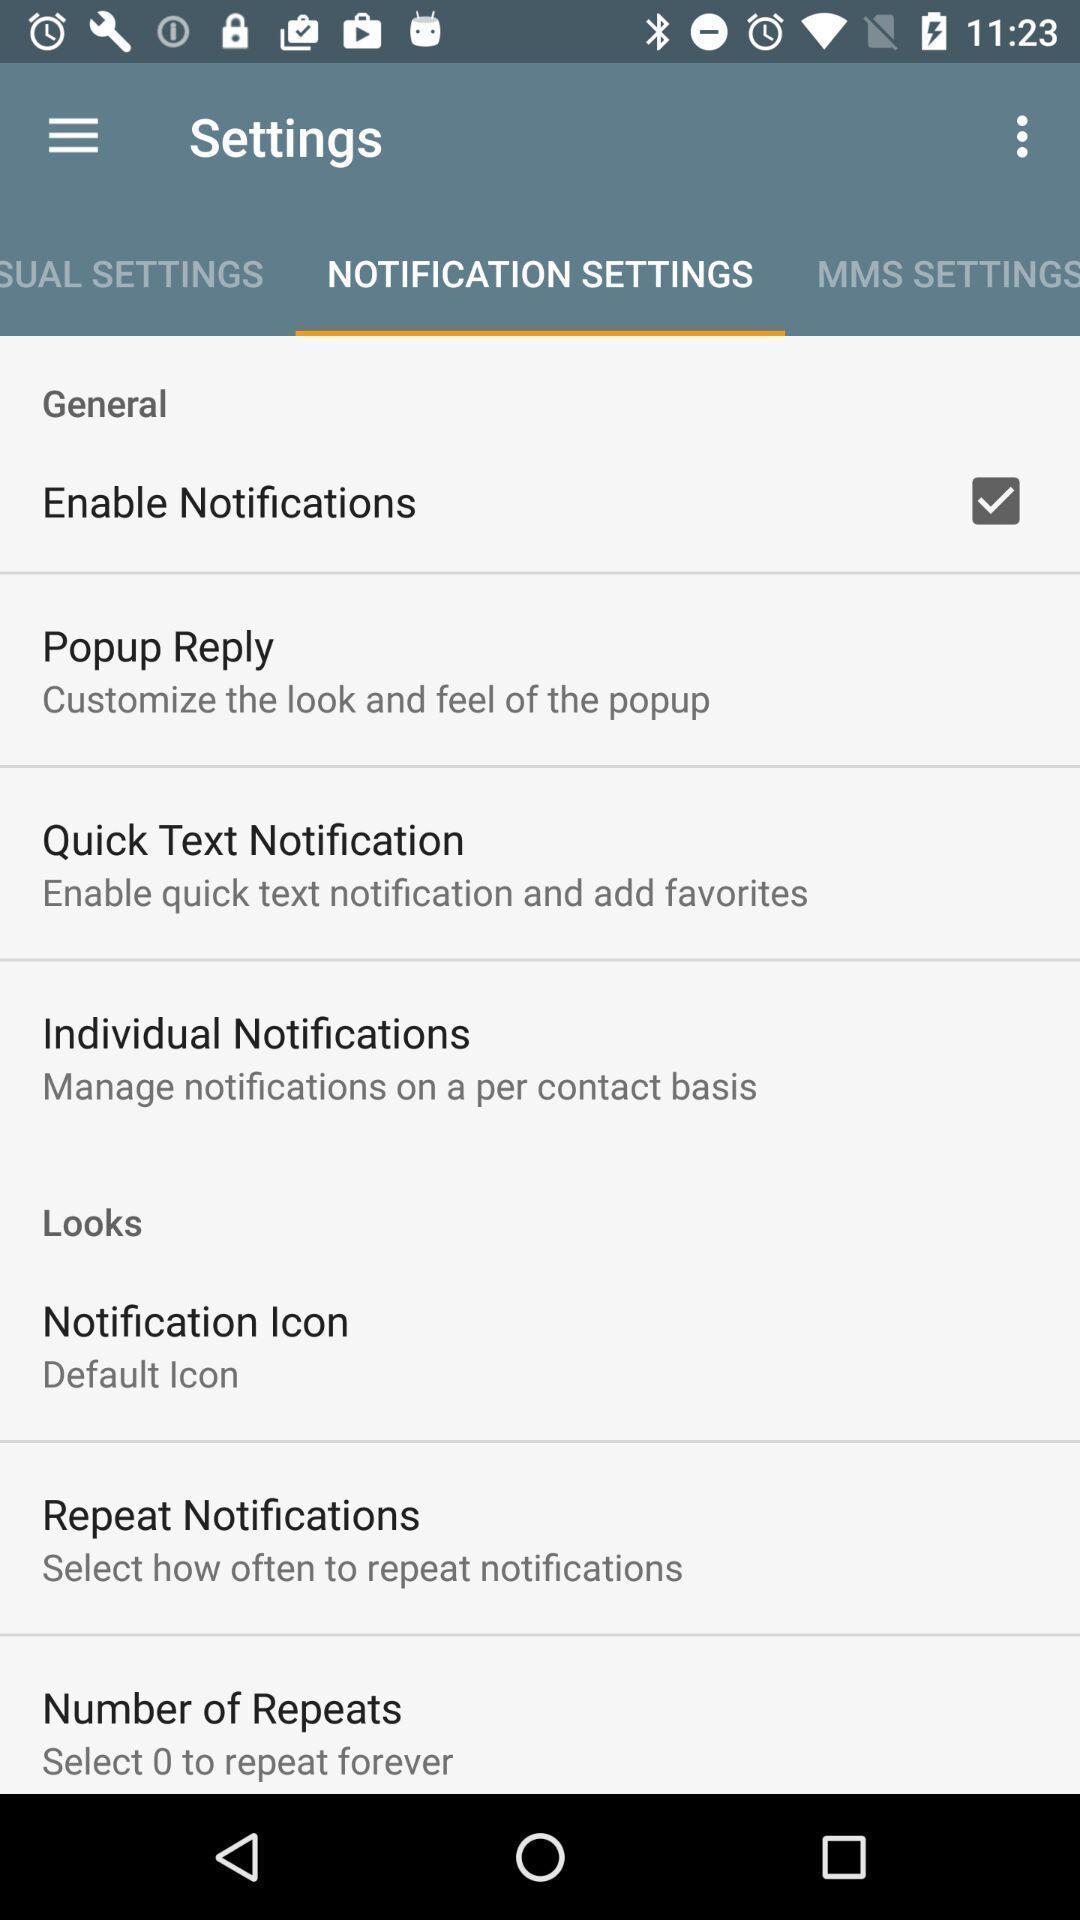Describe this image in words. Settings page displayed. 